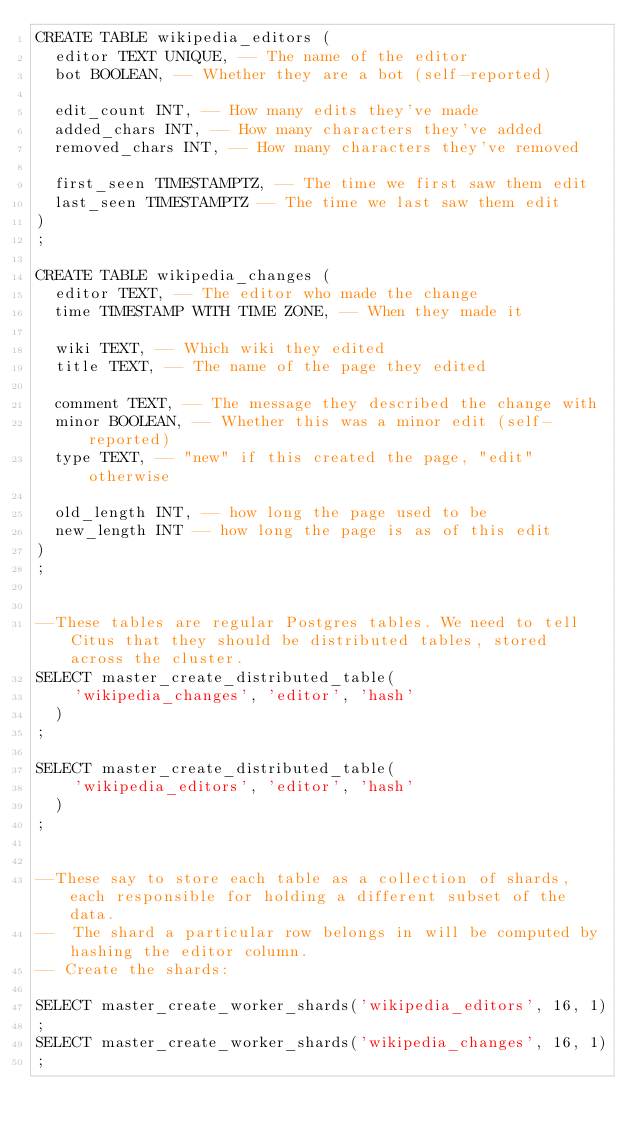Convert code to text. <code><loc_0><loc_0><loc_500><loc_500><_SQL_>CREATE TABLE wikipedia_editors (
  editor TEXT UNIQUE, -- The name of the editor
  bot BOOLEAN, -- Whether they are a bot (self-reported)

  edit_count INT, -- How many edits they've made
  added_chars INT, -- How many characters they've added
  removed_chars INT, -- How many characters they've removed

  first_seen TIMESTAMPTZ, -- The time we first saw them edit
  last_seen TIMESTAMPTZ -- The time we last saw them edit
)
;

CREATE TABLE wikipedia_changes (
  editor TEXT, -- The editor who made the change
  time TIMESTAMP WITH TIME ZONE, -- When they made it

  wiki TEXT, -- Which wiki they edited
  title TEXT, -- The name of the page they edited

  comment TEXT, -- The message they described the change with
  minor BOOLEAN, -- Whether this was a minor edit (self-reported)
  type TEXT, -- "new" if this created the page, "edit" otherwise

  old_length INT, -- how long the page used to be
  new_length INT -- how long the page is as of this edit
)
;


--These tables are regular Postgres tables. We need to tell Citus that they should be distributed tables, stored across the cluster.
SELECT master_create_distributed_table(
    'wikipedia_changes', 'editor', 'hash'
  )
;

SELECT master_create_distributed_table(
    'wikipedia_editors', 'editor', 'hash'
  )
;


--These say to store each table as a collection of shards, each responsible for holding a different subset of the data.
--  The shard a particular row belongs in will be computed by hashing the editor column.
-- Create the shards:

SELECT master_create_worker_shards('wikipedia_editors', 16, 1)
;
SELECT master_create_worker_shards('wikipedia_changes', 16, 1)
;


</code> 